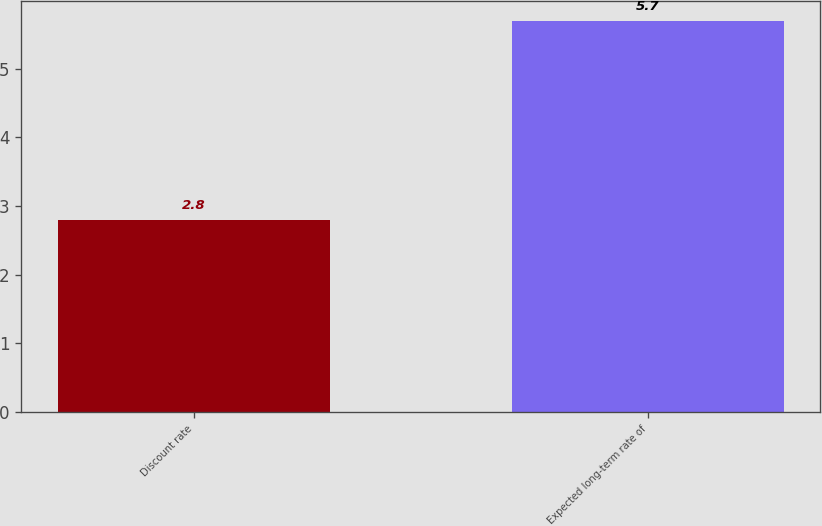Convert chart. <chart><loc_0><loc_0><loc_500><loc_500><bar_chart><fcel>Discount rate<fcel>Expected long-term rate of<nl><fcel>2.8<fcel>5.7<nl></chart> 